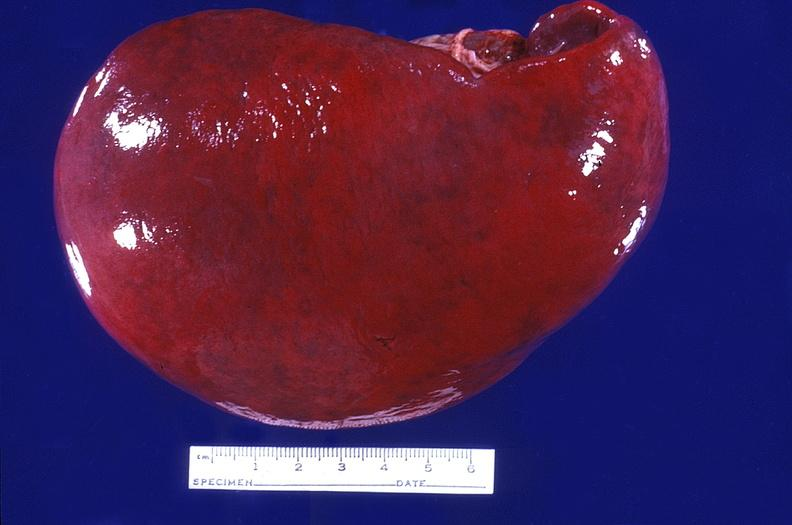s hematologic present?
Answer the question using a single word or phrase. Yes 